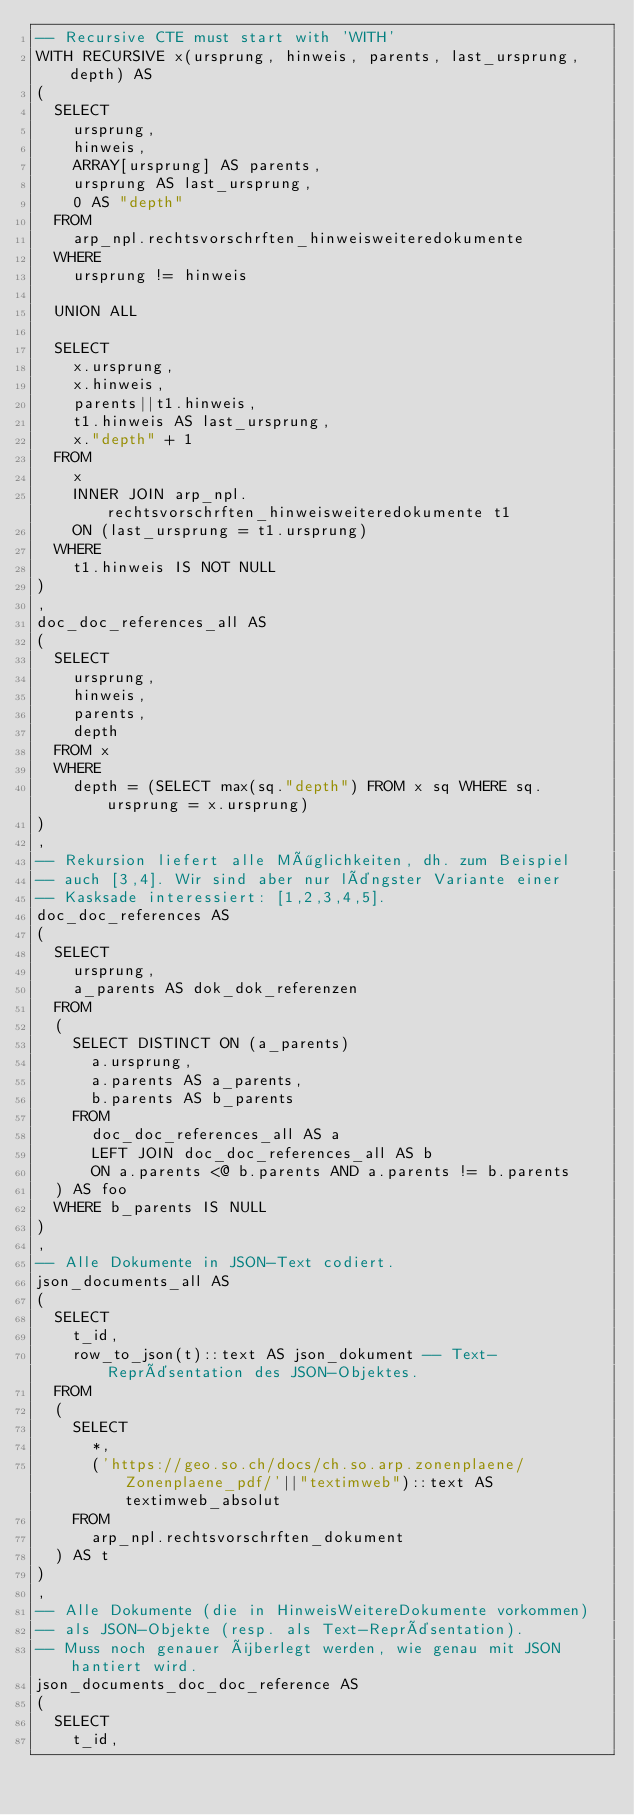Convert code to text. <code><loc_0><loc_0><loc_500><loc_500><_SQL_>-- Recursive CTE must start with 'WITH'
WITH RECURSIVE x(ursprung, hinweis, parents, last_ursprung, depth) AS 
(
  SELECT 
    ursprung, 
    hinweis, 
    ARRAY[ursprung] AS parents, 
    ursprung AS last_ursprung, 
    0 AS "depth" 
  FROM 
    arp_npl.rechtsvorschrften_hinweisweiteredokumente
  WHERE
    ursprung != hinweis

  UNION ALL
  
  SELECT 
    x.ursprung, 
    x.hinweis, 
    parents||t1.hinweis, 
    t1.hinweis AS last_ursprung, 
    x."depth" + 1
  FROM 
    x 
    INNER JOIN arp_npl.rechtsvorschrften_hinweisweiteredokumente t1 
    ON (last_ursprung = t1.ursprung)
  WHERE 
    t1.hinweis IS NOT NULL
)
, 
doc_doc_references_all AS 
(
  SELECT 
    ursprung, 
    hinweis, 
    parents,
    depth
  FROM x 
  WHERE 
    depth = (SELECT max(sq."depth") FROM x sq WHERE sq.ursprung = x.ursprung)
)
,
-- Rekursion liefert alle Möglichkeiten, dh. zum Beispiel
-- auch [3,4]. Wir sind aber nur längster Variante einer 
-- Kasksade interessiert: [1,2,3,4,5].
doc_doc_references AS 
(
  SELECT 
    ursprung,
    a_parents AS dok_dok_referenzen
  FROM
  (
    SELECT DISTINCT ON (a_parents)
      a.ursprung,
      a.parents AS a_parents,
      b.parents AS b_parents
    FROM
      doc_doc_references_all AS a
      LEFT JOIN doc_doc_references_all AS b
      ON a.parents <@ b.parents AND a.parents != b.parents
  ) AS foo
  WHERE b_parents IS NULL
)
,
-- Alle Dokumente in JSON-Text codiert.
json_documents_all AS 
(
  SELECT
    t_id, 
    row_to_json(t)::text AS json_dokument -- Text-Repräsentation des JSON-Objektes. 
  FROM
  (
    SELECT
      *,
      ('https://geo.so.ch/docs/ch.so.arp.zonenplaene/Zonenplaene_pdf/'||"textimweb")::text AS textimweb_absolut
    FROM
      arp_npl.rechtsvorschrften_dokument
  ) AS t
)
,
-- Alle Dokumente (die in HinweisWeitereDokumente vorkommen) 
-- als JSON-Objekte (resp. als Text-Repräsentation).
-- Muss noch genauer überlegt werden, wie genau mit JSON hantiert wird.
json_documents_doc_doc_reference AS 
(
  SELECT
    t_id, </code> 